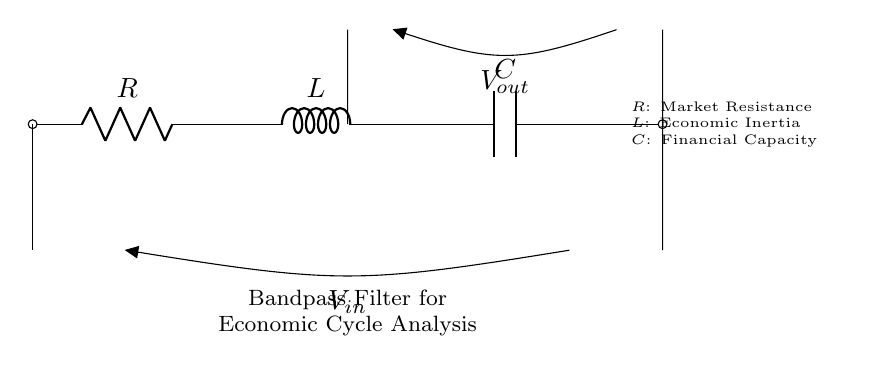What are the components in this circuit? The circuit contains three components: a resistor, an inductor, and a capacitor. These are indicated by their symbols in the diagram.
Answer: Resistor, Inductor, Capacitor What does the resistor represent? The resistor in the diagram symbolizes market resistance; this can be seen in the label next to the resistor symbol.
Answer: Market Resistance What is the relationship of voltage to the circuit diagram? The circuit shows two voltage points, Vin and Vout, where Vin is the input voltage and Vout is the output voltage. This indicates how voltage is managed through the components.
Answer: Vin, Vout Why is it referred to as a bandpass filter? A bandpass filter allows signals within a certain frequency range to pass through while attenuating signals outside that range, similar to how economic cycles have specific periods of activity.
Answer: Because it allows specific frequencies How does the inductor affect the circuit? The inductor, representing economic inertia, stores energy in a magnetic field when current flows. It affects the current depending on the frequency of the signal, which can cause phase shifts and affect stability.
Answer: Stores energy, creates phase shifts What is the function of the capacitor in this circuit? The capacitor's role is to store and release energy, acting as a filter to smooth out fluctuations; it represents financial capacity. The capacitor responds differently to varying frequencies, allowing specific signals to be processed.
Answer: Stores and releases energy What overall economic concept does the circuit depict? The circuit represents the cyclical nature of economic patterns, where each component correlates to different factors in economic analysis, demonstrating how resistive, inertial, and capacitive effects interact.
Answer: Economic Cycle Analysis 